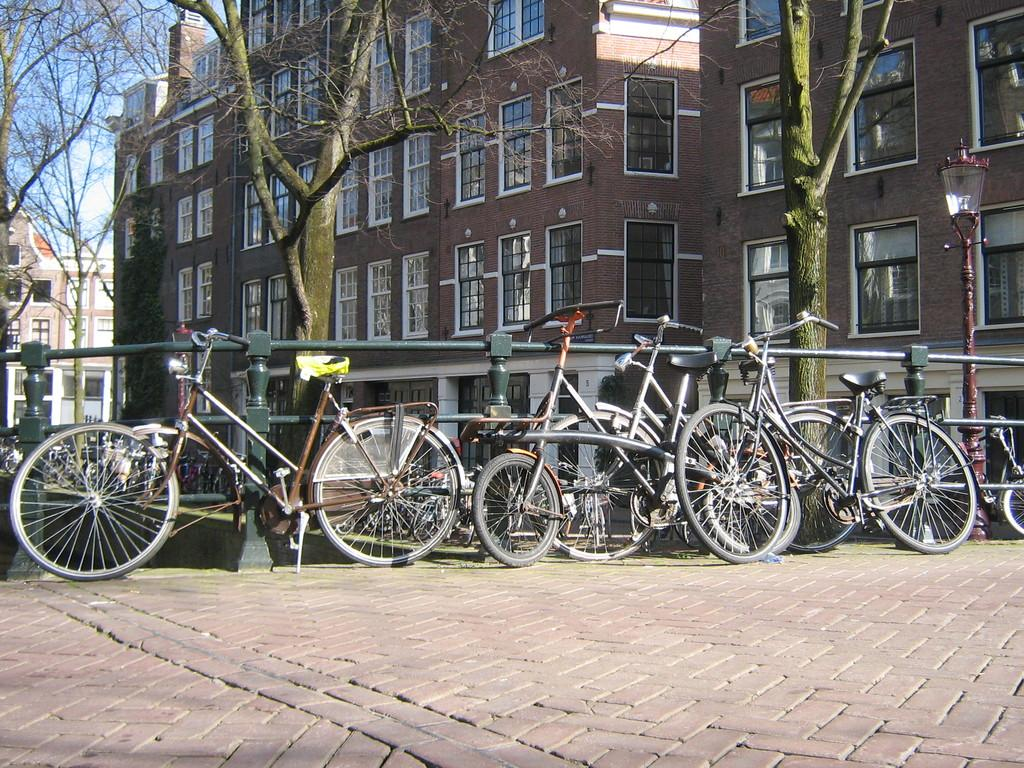What type of vehicles are in the image? There are bicycles in the image. What can be seen near the bicycles? There is a railing in the image. What is visible in the background of the image? There are trees, buildings, and the sky visible in the background of the image. How many deer can be seen swimming in the sea in the image? There are no deer or sea present in the image. 